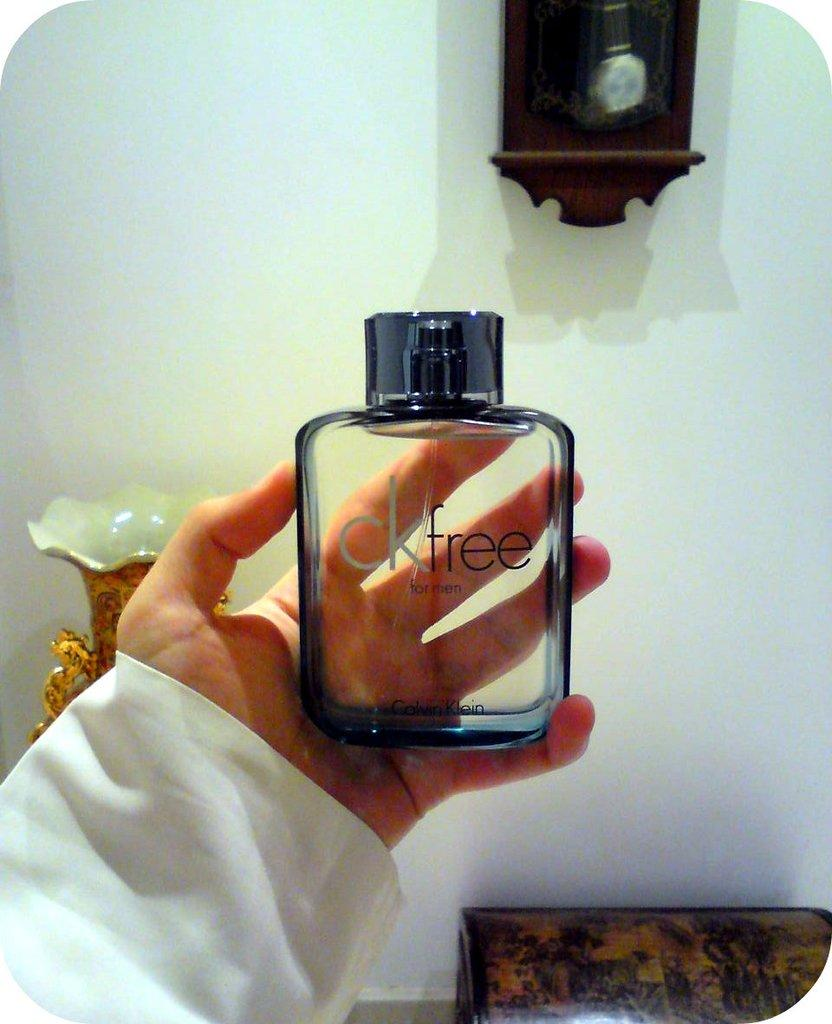<image>
Provide a brief description of the given image. A person holds a spray bottle of CK Free in their left hand. 